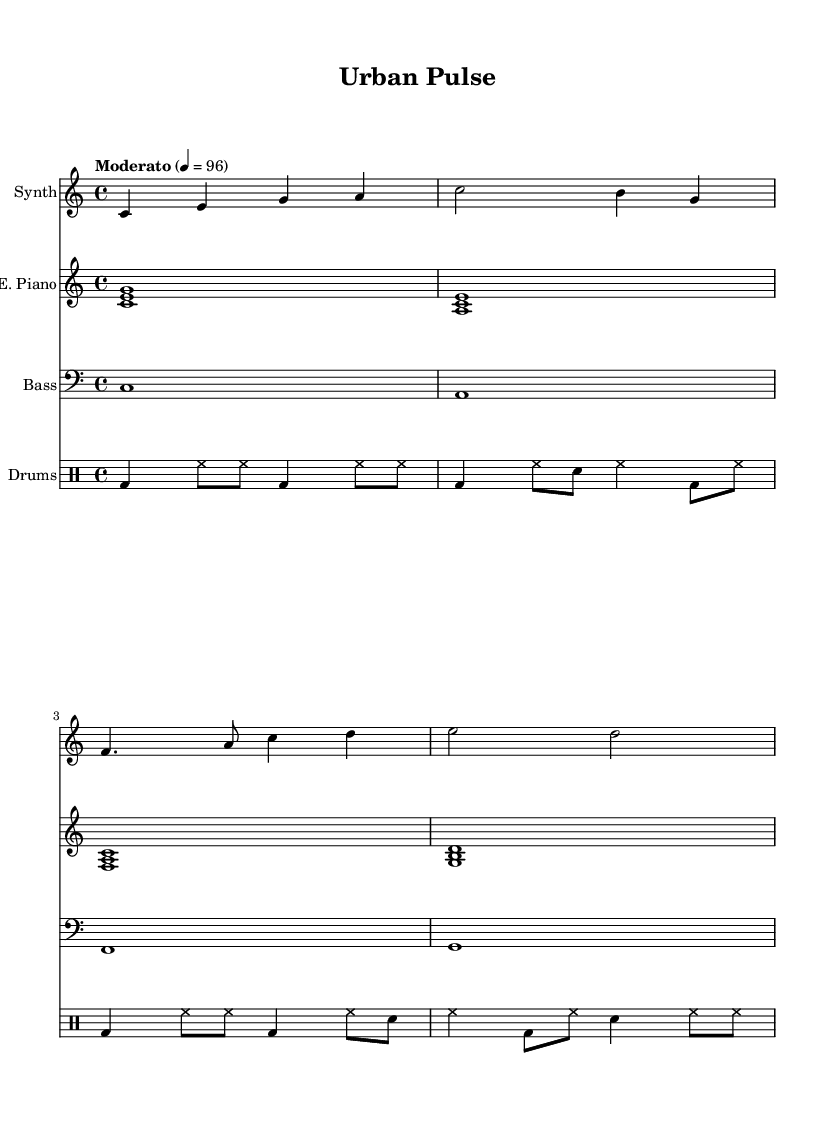What is the key signature of this music? The key signature is C major, which is indicated by the lack of sharps or flats at the beginning of the staff.
Answer: C major What is the time signature of this composition? The time signature is indicated at the beginning of the score as 4/4, meaning there are four beats per measure and the quarter note gets one beat.
Answer: 4/4 What is the tempo marking of this piece? The tempo is marked as "Moderato" with a metronome indication of 4 = 96, which suggests a moderate pace at 96 beats per minute.
Answer: Moderato How many measures are in the synthesizer part? By counting the distinct groups of notes separated by vertical lines, there are 4 measures in the synthesizer part.
Answer: 4 What is the overall mood suggested by the instrumentation used in this piece? The combination of synthesized sounds, an electric piano, bass synth, and drum machine typically conveys a modern, urban feel, evoking a bustling cityscape.
Answer: Urban Which instrument plays the first harmonic chord? The first harmonic chord is played by the electric piano, as indicated by the specific note arrangement at the start of its part.
Answer: Electric Piano How does the drum machine contribute to the urban theme of the music? The drum machine uses rhythmic patterns typical of urban electronic music, creating a driving pulse that mimics the energy of city life through its beats.
Answer: Driving pulse 